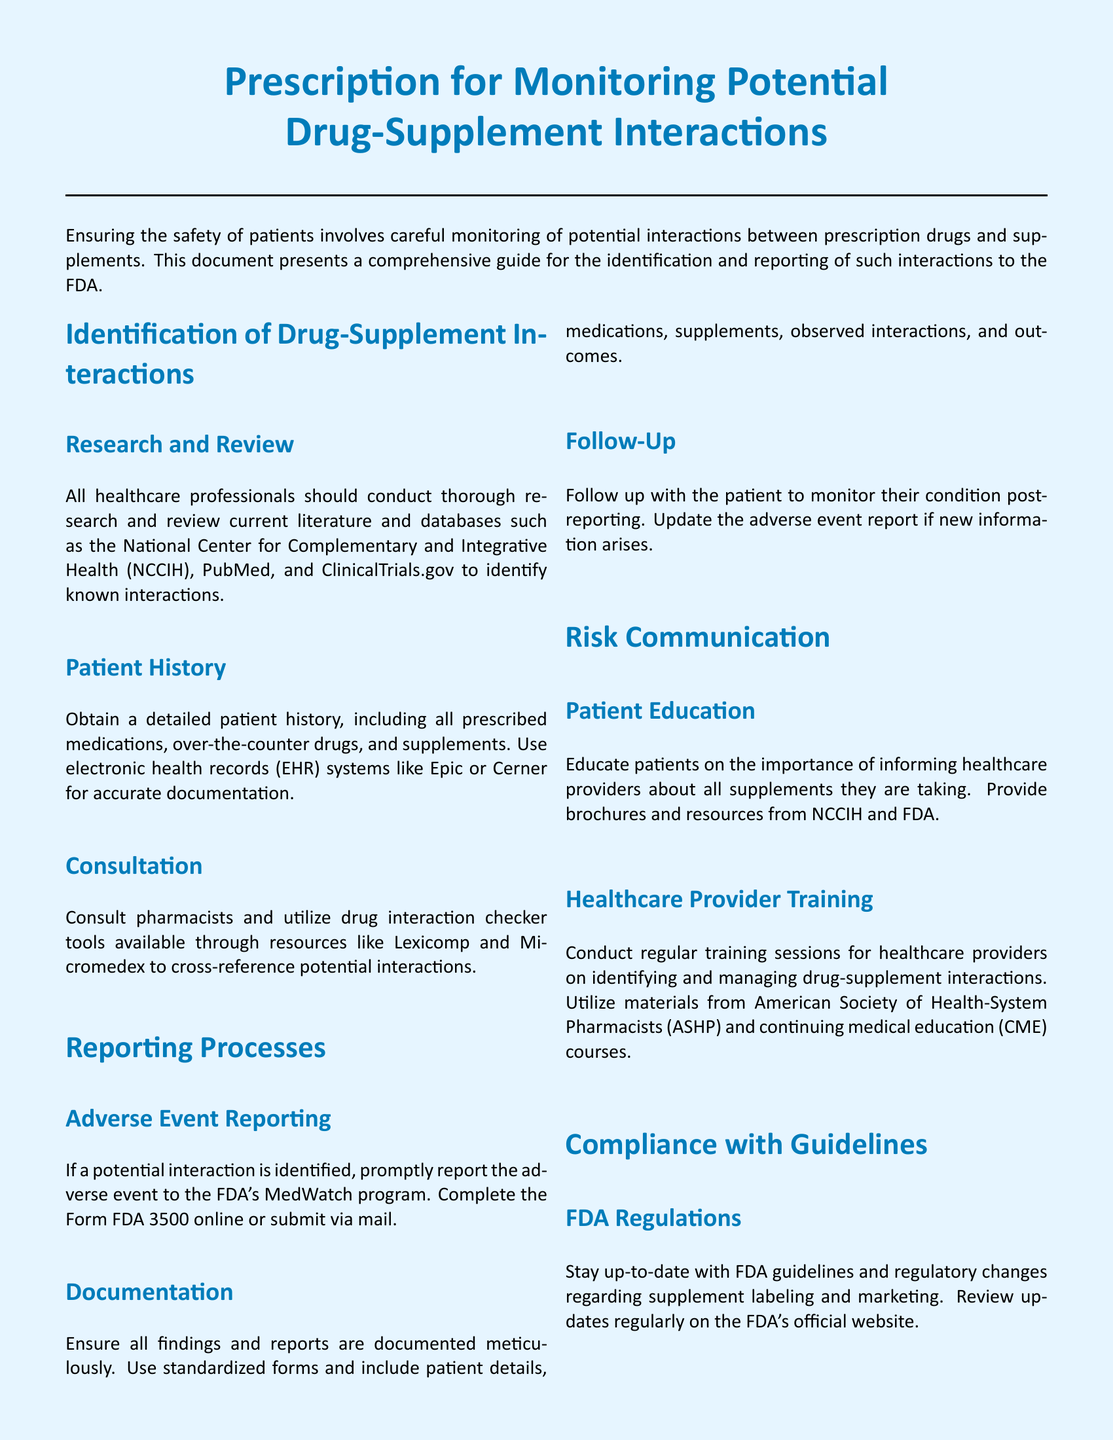What is the main focus of the document? The main focus of the document is to provide guidance on monitoring potential drug-supplement interactions.
Answer: monitoring potential drug-supplement interactions Which program should adverse events be reported to? The document specifies that adverse events should be reported to the FDA's MedWatch program.
Answer: FDA's MedWatch program What tools are recommended for consulting regarding drug interactions? The document lists drug interaction checker tools such as Lexicomp and Micromedex.
Answer: Lexicomp and Micromedex What should be documented when reporting an adverse event? The documentation should include patient details, medications, supplements, observed interactions, and outcomes.
Answer: patient details, medications, supplements, observed interactions, and outcomes Who should be educated about the importance of informing healthcare providers? The document emphasizes that patients should be educated about informing healthcare providers concerning supplements.
Answer: patients What are the two main sections of the reporting processes? The two main sections are Adverse Event Reporting and Documentation.
Answer: Adverse Event Reporting and Documentation What organization is responsible for issuing the prescription? The document states that the FDA is responsible for issuing the prescription.
Answer: FDA What type of training is suggested for healthcare providers? The document suggests conducting regular training sessions for healthcare providers on identifying and managing drug-supplement interactions.
Answer: regular training sessions 